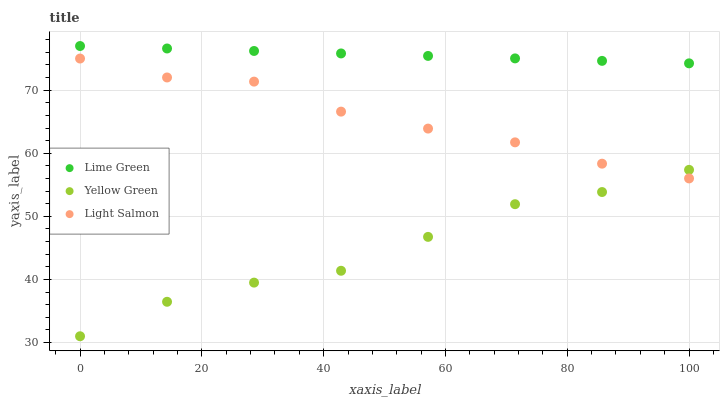Does Yellow Green have the minimum area under the curve?
Answer yes or no. Yes. Does Lime Green have the maximum area under the curve?
Answer yes or no. Yes. Does Lime Green have the minimum area under the curve?
Answer yes or no. No. Does Yellow Green have the maximum area under the curve?
Answer yes or no. No. Is Lime Green the smoothest?
Answer yes or no. Yes. Is Yellow Green the roughest?
Answer yes or no. Yes. Is Yellow Green the smoothest?
Answer yes or no. No. Is Lime Green the roughest?
Answer yes or no. No. Does Yellow Green have the lowest value?
Answer yes or no. Yes. Does Lime Green have the lowest value?
Answer yes or no. No. Does Lime Green have the highest value?
Answer yes or no. Yes. Does Yellow Green have the highest value?
Answer yes or no. No. Is Light Salmon less than Lime Green?
Answer yes or no. Yes. Is Lime Green greater than Yellow Green?
Answer yes or no. Yes. Does Yellow Green intersect Light Salmon?
Answer yes or no. Yes. Is Yellow Green less than Light Salmon?
Answer yes or no. No. Is Yellow Green greater than Light Salmon?
Answer yes or no. No. Does Light Salmon intersect Lime Green?
Answer yes or no. No. 